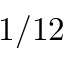<formula> <loc_0><loc_0><loc_500><loc_500>1 / 1 2</formula> 